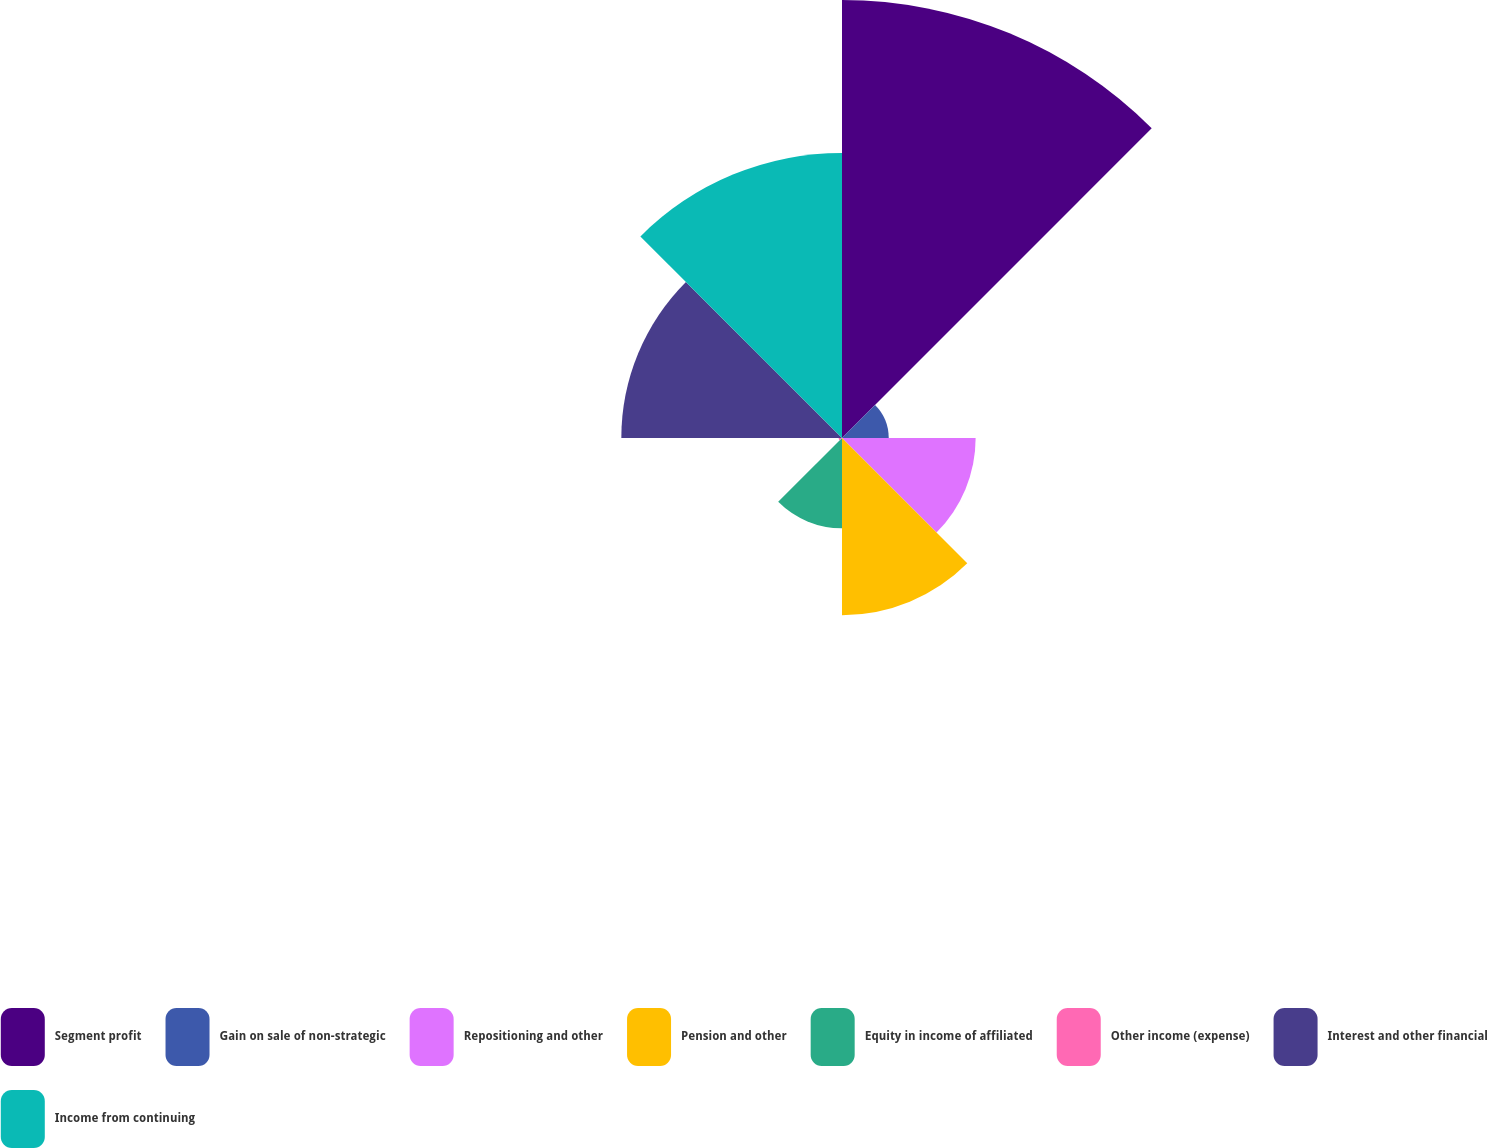Convert chart. <chart><loc_0><loc_0><loc_500><loc_500><pie_chart><fcel>Segment profit<fcel>Gain on sale of non-strategic<fcel>Repositioning and other<fcel>Pension and other<fcel>Equity in income of affiliated<fcel>Other income (expense)<fcel>Interest and other financial<fcel>Income from continuing<nl><fcel>31.4%<fcel>3.35%<fcel>9.58%<fcel>12.7%<fcel>6.47%<fcel>0.24%<fcel>15.82%<fcel>20.44%<nl></chart> 